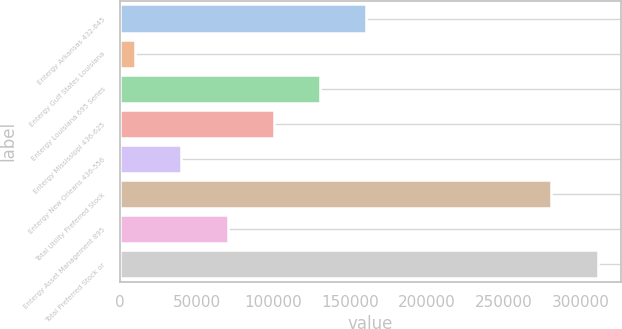Convert chart to OTSL. <chart><loc_0><loc_0><loc_500><loc_500><bar_chart><fcel>Entergy Arkansas 432-645<fcel>Entergy Gulf States Louisiana<fcel>Entergy Louisiana 695 Series<fcel>Entergy Mississippi 436-625<fcel>Entergy New Orleans 436-556<fcel>Total Utility Preferred Stock<fcel>Entergy Asset Management 895<fcel>Total Preferred Stock or<nl><fcel>160514<fcel>10000<fcel>130412<fcel>100309<fcel>40102.9<fcel>280511<fcel>70205.8<fcel>311029<nl></chart> 